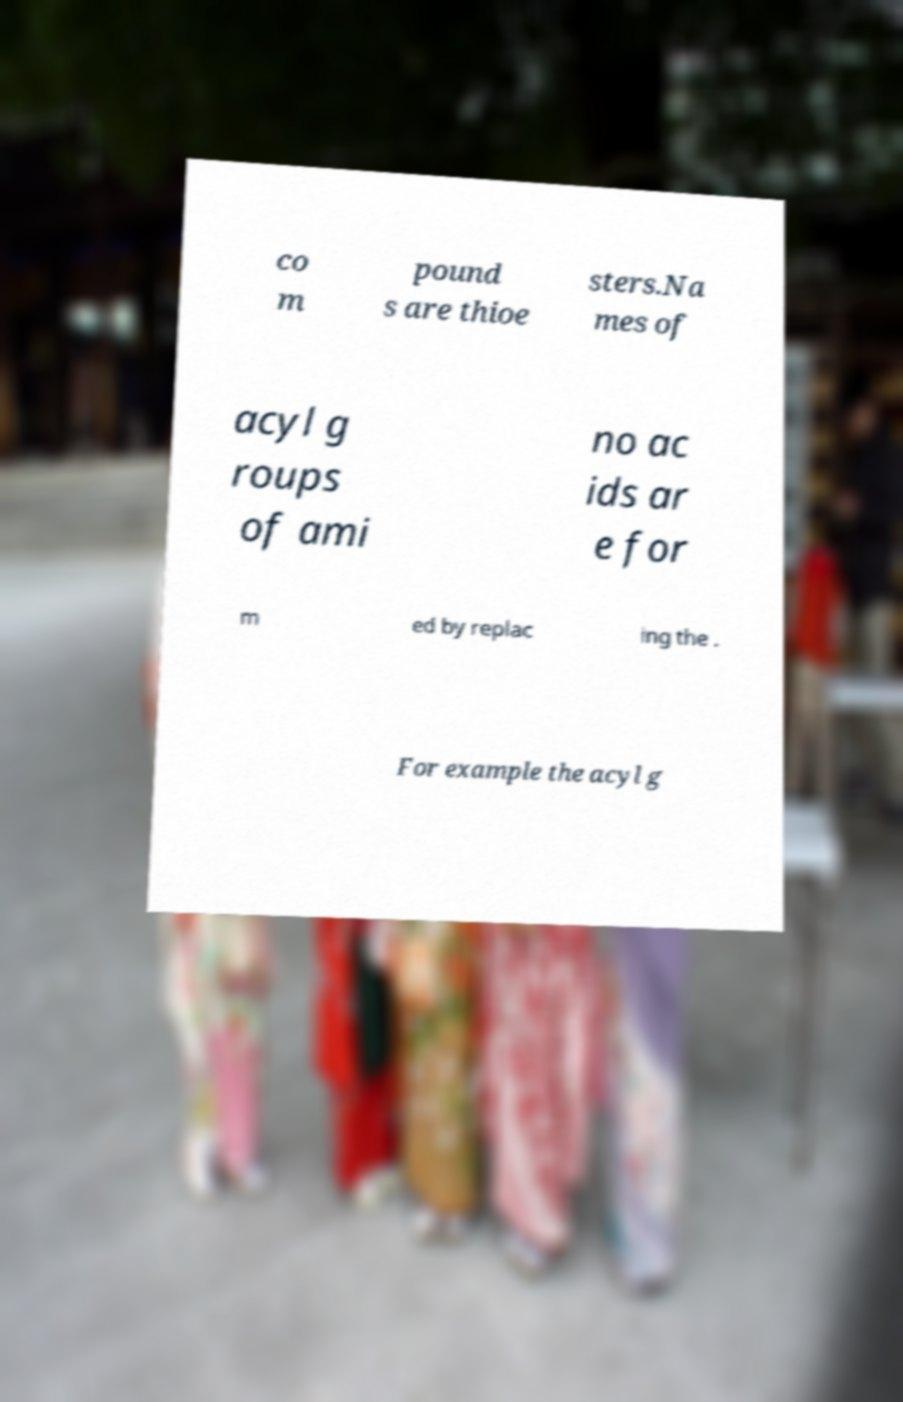Can you read and provide the text displayed in the image?This photo seems to have some interesting text. Can you extract and type it out for me? co m pound s are thioe sters.Na mes of acyl g roups of ami no ac ids ar e for m ed by replac ing the . For example the acyl g 